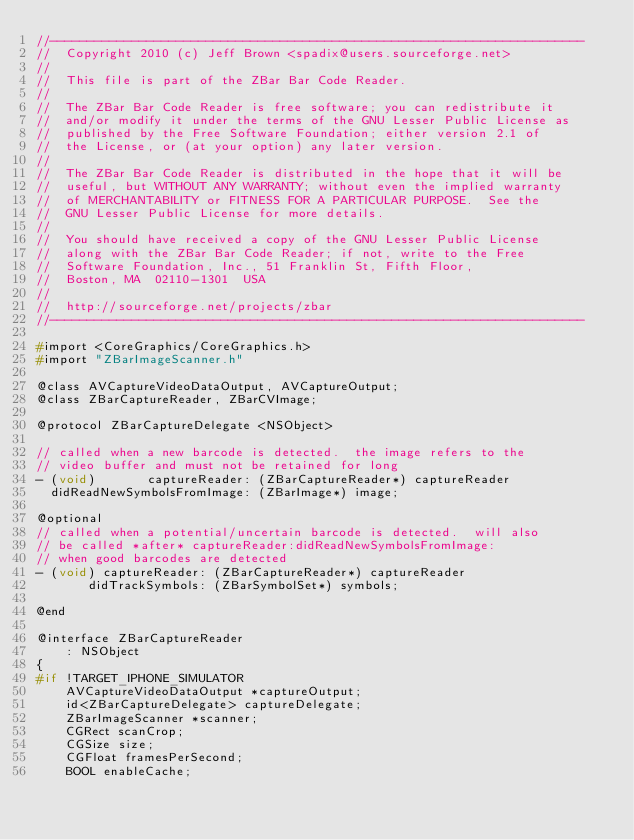Convert code to text. <code><loc_0><loc_0><loc_500><loc_500><_C_>//------------------------------------------------------------------------
//  Copyright 2010 (c) Jeff Brown <spadix@users.sourceforge.net>
//
//  This file is part of the ZBar Bar Code Reader.
//
//  The ZBar Bar Code Reader is free software; you can redistribute it
//  and/or modify it under the terms of the GNU Lesser Public License as
//  published by the Free Software Foundation; either version 2.1 of
//  the License, or (at your option) any later version.
//
//  The ZBar Bar Code Reader is distributed in the hope that it will be
//  useful, but WITHOUT ANY WARRANTY; without even the implied warranty
//  of MERCHANTABILITY or FITNESS FOR A PARTICULAR PURPOSE.  See the
//  GNU Lesser Public License for more details.
//
//  You should have received a copy of the GNU Lesser Public License
//  along with the ZBar Bar Code Reader; if not, write to the Free
//  Software Foundation, Inc., 51 Franklin St, Fifth Floor,
//  Boston, MA  02110-1301  USA
//
//  http://sourceforge.net/projects/zbar
//------------------------------------------------------------------------

#import <CoreGraphics/CoreGraphics.h>
#import "ZBarImageScanner.h"

@class AVCaptureVideoDataOutput, AVCaptureOutput;
@class ZBarCaptureReader, ZBarCVImage;

@protocol ZBarCaptureDelegate <NSObject>

// called when a new barcode is detected.  the image refers to the
// video buffer and must not be retained for long
- (void)       captureReader: (ZBarCaptureReader*) captureReader
  didReadNewSymbolsFromImage: (ZBarImage*) image;

@optional
// called when a potential/uncertain barcode is detected.  will also
// be called *after* captureReader:didReadNewSymbolsFromImage:
// when good barcodes are detected
- (void) captureReader: (ZBarCaptureReader*) captureReader
       didTrackSymbols: (ZBarSymbolSet*) symbols;

@end

@interface ZBarCaptureReader
    : NSObject
{
#if !TARGET_IPHONE_SIMULATOR
    AVCaptureVideoDataOutput *captureOutput;
    id<ZBarCaptureDelegate> captureDelegate;
    ZBarImageScanner *scanner;
    CGRect scanCrop;
    CGSize size;
    CGFloat framesPerSecond;
    BOOL enableCache;
</code> 